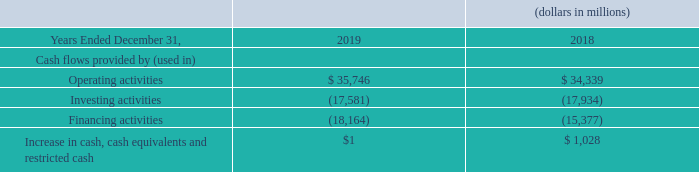Capital Expenditures
Our 2020 capital program includes capital to fund advanced networks and services, including expanding our core networks, adding capacity and density to our 4G LTE network in order to stay ahead of our customers’ increasing data demands and deploying our 5G network, transforming our structure to deploy the Intelligent Edge Network while reducing the cost to deliver services to our customers, and pursuing other opportunities to drive operating efficiencies. We expect that the new network architecture will simplify operations by eliminating legacy network elements, improve our 4G LTE coverage, speed the deployment of 5G technology, and create new enterprise opportunities in the business market. The level and the timing of the Company’s capital expenditures within these broad categories can vary significantly as a result of a variety of factors outside of our control, such as material weather events, equipment availability from vendors and permits from local governments. Capital expenditures for 2020 are expected to be in the range of $17.0 billion to $18.0 billion, including the continued investment in our 5G network. Capital expenditures were $17.9 billion in 2019 and $16.7 billion in 2018. We believe that we have significant discretion over the amount and timing of our capital expenditures on a Company-wide basis as we are not subject to any agreement that would require significant capital expenditures on a designated schedule or upon the occurrence of designated events.
Consolidated Financial Condition
We use the net cash generated from our operations to fund expansion and modernization of our networks, service and repay external financing, pay dividends, invest in new businesses and spectrum and, when appropriate, buy back shares of our outstanding common stock. Our sources of funds, primarily from operations and, to the extent necessary, from external financing arrangements, are sufficient to meet ongoing operating and investing requirements.
We expect that our capital spending requirements will continue to be financed primarily through internally generated funds. Debt or equity financing may be needed to fund additional investments or development activities or to maintain an appropriate capital structure to ensure our financial flexibility. Our cash and cash equivalents are held both domestically and internationally, and are invested to maintain principal and provide liquidity. See “Market Risk” for additional information regarding our foreign currency risk management strategies.
Our available external financing arrangements include an active commercial paper program, credit available under credit facilities and other bank lines of credit, vendor financing arrangements, issuances of registered debt or equity securities, U.S. retail medium-term notes and other capital market securities that are privately-placed or offered overseas. In addition, we monetize our device payment plan agreement receivables through asset-backed debt transactions.
How is the capital spending requirements for the firm financed? Primarily through internally generated funds. What are the available external financing arrangements? Active commercial paper program, credit available under credit facilities and other bank lines of credit, vendor financing arrangements, issuances of registered debt or equity securities, u.s. retail medium-term notes and other capital market securities that are privately-placed or offered overseas. What was the cash flow from operating activities in 2019?
Answer scale should be: million. $ 35,746. What was the change in cash flow from operating activities from 2018 to 2019?
Answer scale should be: million. 35,746 - 34,339
Answer: 1407. What was the average cash flow used in investing activities for 2018 and 2019?
Answer scale should be: million. -(17,581 + 17,934) / 2
Answer: -17757.5. What was the percentage change in cash flow used in financing activities from 2018 to 2019?
Answer scale should be: percent. -18,164 / -15,377 - 1
Answer: 18.12. 